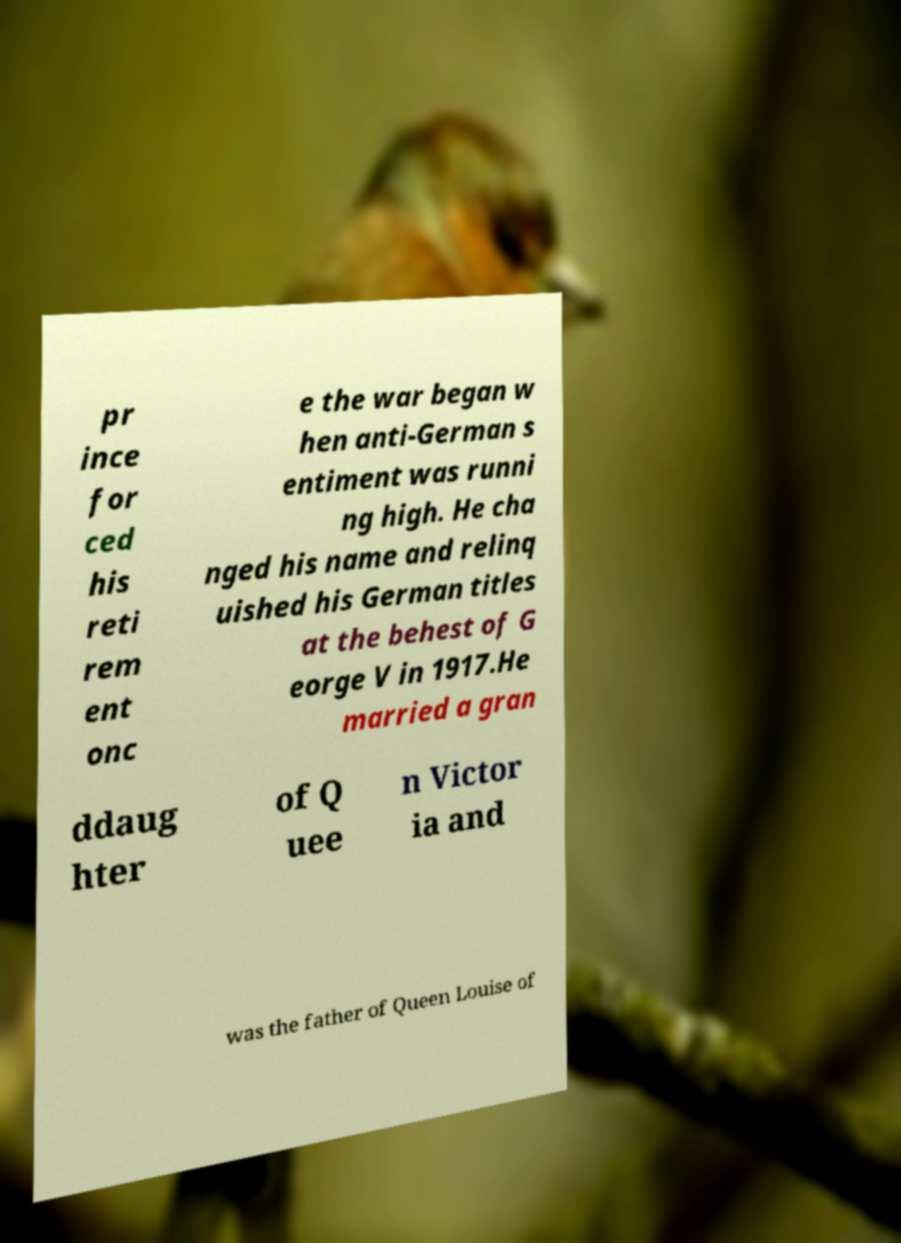For documentation purposes, I need the text within this image transcribed. Could you provide that? pr ince for ced his reti rem ent onc e the war began w hen anti-German s entiment was runni ng high. He cha nged his name and relinq uished his German titles at the behest of G eorge V in 1917.He married a gran ddaug hter of Q uee n Victor ia and was the father of Queen Louise of 